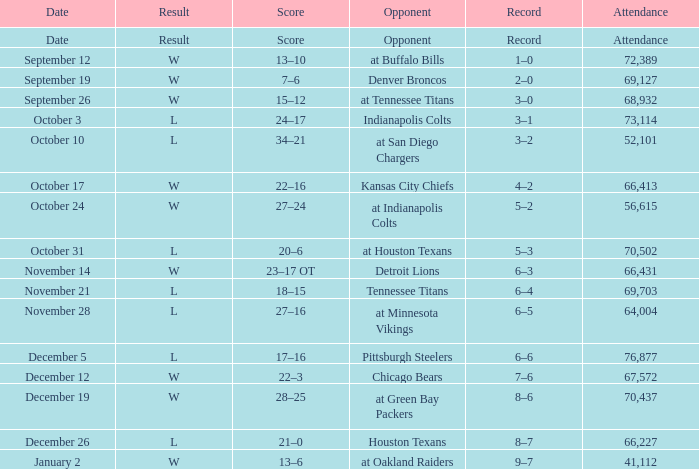What score holds the october 31 date? 20–6. 